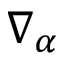<formula> <loc_0><loc_0><loc_500><loc_500>\nabla _ { \alpha }</formula> 